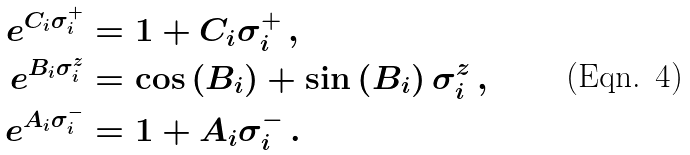<formula> <loc_0><loc_0><loc_500><loc_500>e ^ { C _ { i } \sigma _ { i } ^ { + } } & = 1 + C _ { i } \sigma _ { i } ^ { + } \, , \\ e ^ { B _ { i } \sigma _ { i } ^ { z } } & = \cos \left ( B _ { i } \right ) + \sin \left ( B _ { i } \right ) \sigma _ { i } ^ { z } \, , \\ e ^ { A _ { i } \sigma _ { i } ^ { - } } & = 1 + A _ { i } \sigma _ { i } ^ { - } \, .</formula> 